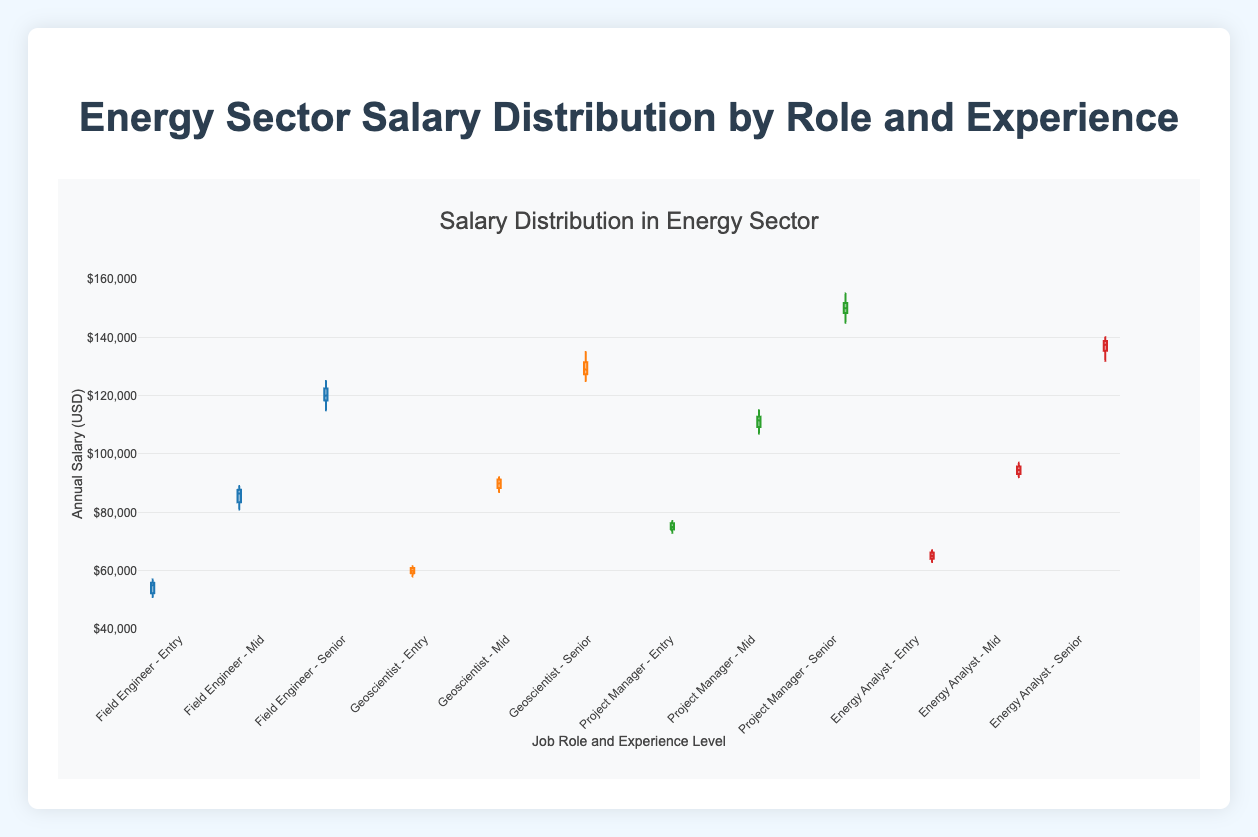What is the title of the plot? The title of the plot is usually found at the top of the figure, and in this case, it reads "Salary Distribution in Energy Sector".
Answer: Salary Distribution in Energy Sector What does the y-axis represent, and what are its units? The y-axis represents the annual salary of employees in the energy sector, specified in USD.
Answer: Annual Salary (USD) Which role and experience level combination has the highest median salary? To find the highest median salary, we need to look for the middle value of the box plots for each role and experience level combination. The highest median appears to be for the "Project Manager - Senior" combination.
Answer: Project Manager - Senior How do the salaries of Entry-level Geoscientists compare to those of Entry-level Field Engineers? Find the medians of the box plots for both Entry-level Geoscientists and Entry-level Field Engineers. The median salary for Entry-level Geoscientists is higher than that of Entry-level Field Engineers.
Answer: Higher for Geoscientists By how much does the median salary of a Mid-level Project Manager exceed that of a Mid-level Field Engineer? The median salary for a Mid-level Project Manager appears to be around $111,500, while for a Mid-level Field Engineer, it is approximately $86,500. The difference is $111,500 - $86,500.
Answer: $25,000 Which role exhibits the largest interquartile range (IQR) for Senior-level salaries? The interquartile range (IQR) is represented by the length of the box in the box plot. Observing the lengths, "Project Manager - Senior" appears to have the largest IQR.
Answer: Project Manager - Senior Is there any job role and experience level combination that shows suspected outliers? Suspected outliers are indicated by points outside the whiskers of the box plot. "Field Engineer - Entry" shows one suspected outlier.
Answer: Field Engineer - Entry What is the approximate range of salaries for Mid-level Geoscientists? The range is determined by the whiskers of the box plot. For Mid-level Geoscientists, the range appears to be from approximately $87,000 to $92,000.
Answer: $87,000 to $92,000 Which role has the closest median salary across all experience levels? To determine the role with the closest median salaries, compare the medians of Entry, Mid, and Senior levels for each role. "Geoscientist" has relatively close median salaries.
Answer: Geoscientist 